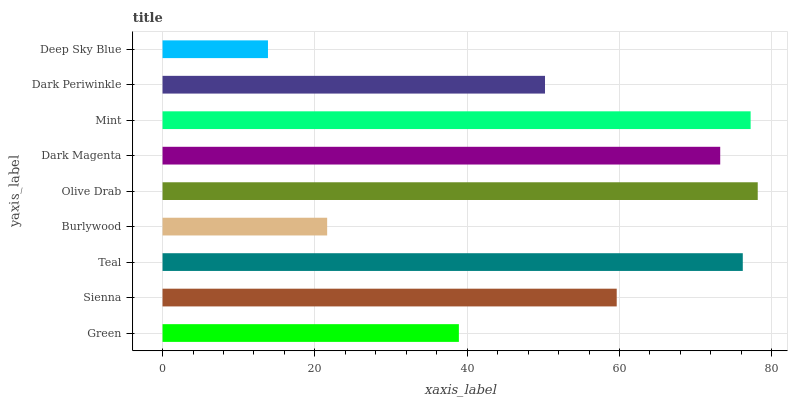Is Deep Sky Blue the minimum?
Answer yes or no. Yes. Is Olive Drab the maximum?
Answer yes or no. Yes. Is Sienna the minimum?
Answer yes or no. No. Is Sienna the maximum?
Answer yes or no. No. Is Sienna greater than Green?
Answer yes or no. Yes. Is Green less than Sienna?
Answer yes or no. Yes. Is Green greater than Sienna?
Answer yes or no. No. Is Sienna less than Green?
Answer yes or no. No. Is Sienna the high median?
Answer yes or no. Yes. Is Sienna the low median?
Answer yes or no. Yes. Is Burlywood the high median?
Answer yes or no. No. Is Olive Drab the low median?
Answer yes or no. No. 